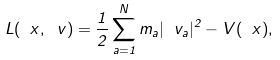Convert formula to latex. <formula><loc_0><loc_0><loc_500><loc_500>L ( \ x , \ v ) = \frac { 1 } { 2 } \sum _ { a = 1 } ^ { N } m _ { a } | \ v _ { a } | ^ { 2 } - V ( \ x ) ,</formula> 